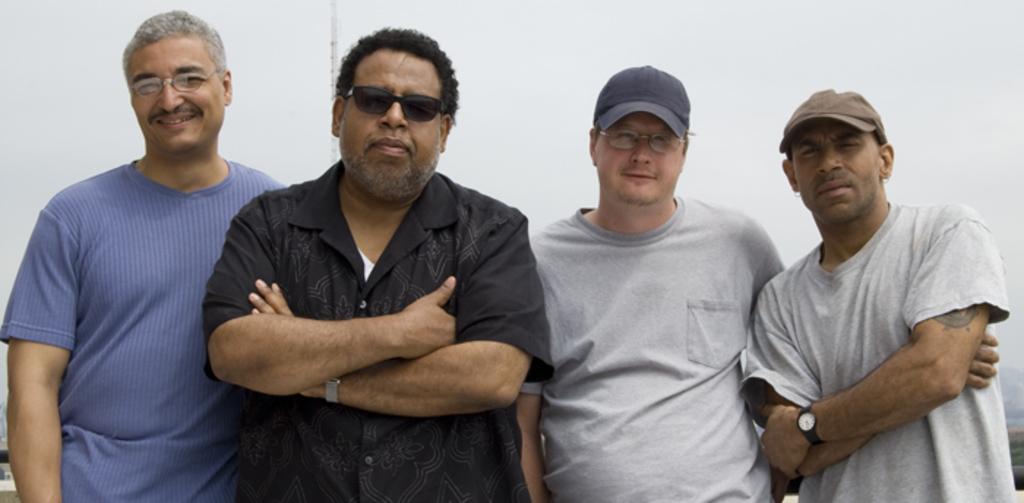In one or two sentences, can you explain what this image depicts? In the picture we can see group of men standing together and posing for a photograph. 